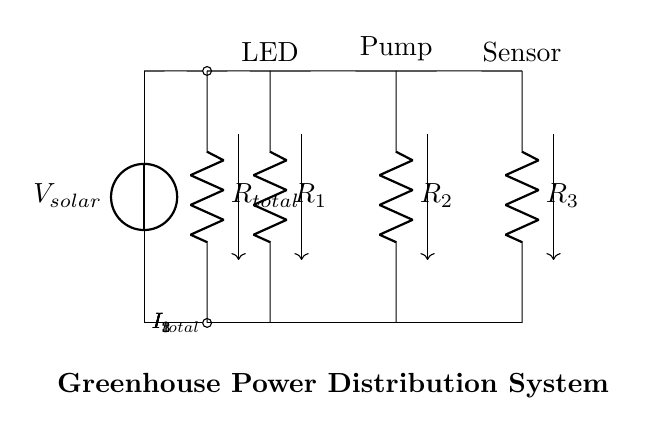What is the total current flowing from the solar panel? The total current \(I_{total}\) is represented by the arrow labeled \(I_{total}\) in the circuit diagram, indicating the current before it splits into the branches.
Answer: I total How many resistors are used in the current divider? The circuit diagram shows three resistors labeled \(R_1\), \(R_2\), and \(R_3\), which are part of the current divider configuration.
Answer: 3 Which device is connected to resistor \(R_2\)? From the diagram, resistor \(R_2\) is connected to the pump, as indicated by the label above it.
Answer: Pump What type of circuit configuration is represented here? The arrangement of resistors in parallel connected to a common voltage source creates a current divider configuration, designed to distribute current to multiple components.
Answer: Current divider What happens to the current through each resistor? The current distributes based on the resistance values; with lower resistance leading to higher current flow and higher resistance leading to lower current flow following Ohm's law.
Answer: It divides What is the purpose of the current divider in this diagram? The current divider distributes energy from the solar panel to the different devices (LED, pump, and sensor) efficiently by managing how much current each device receives based on their resistances.
Answer: Distribute energy 